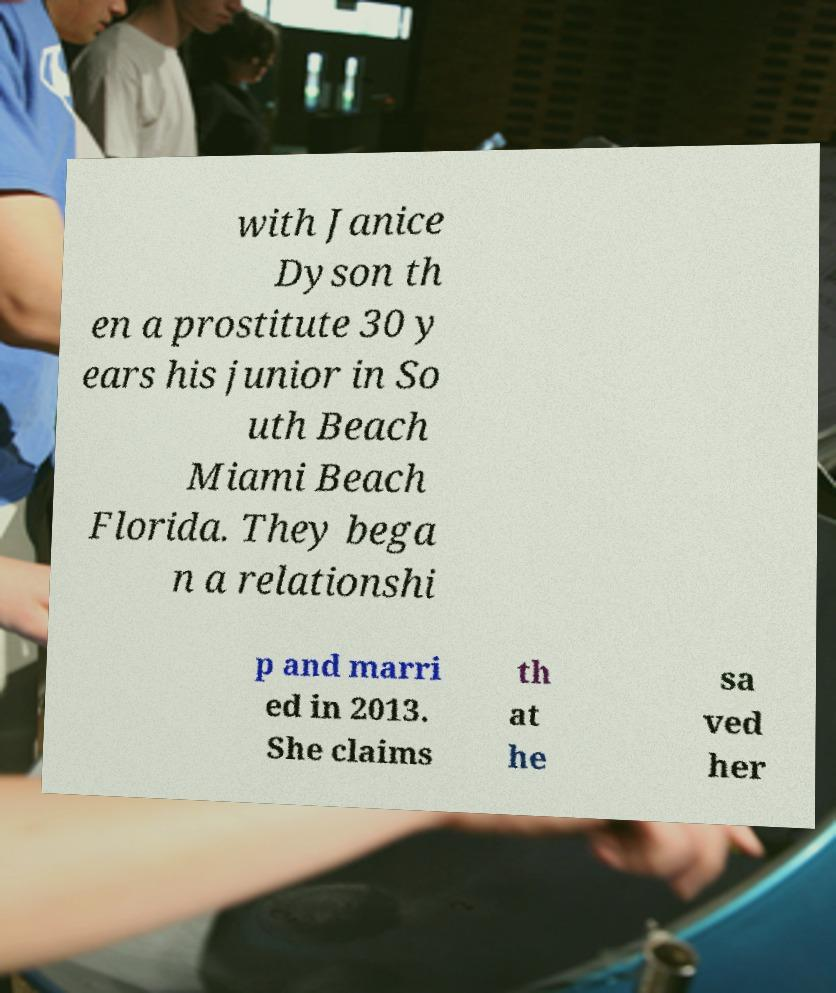Please identify and transcribe the text found in this image. with Janice Dyson th en a prostitute 30 y ears his junior in So uth Beach Miami Beach Florida. They bega n a relationshi p and marri ed in 2013. She claims th at he sa ved her 